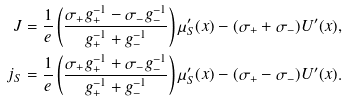Convert formula to latex. <formula><loc_0><loc_0><loc_500><loc_500>J = \frac { 1 } { e } \left ( \frac { \sigma _ { + } g ^ { - 1 } _ { + } - \sigma _ { - } g ^ { - 1 } _ { - } } { g ^ { - 1 } _ { + } + g ^ { - 1 } _ { - } } \right ) \mu ^ { \prime } _ { S } ( x ) - ( \sigma _ { + } + \sigma _ { - } ) U ^ { \prime } ( x ) , \\ j _ { S } = \frac { 1 } { e } \left ( \frac { \sigma _ { + } g ^ { - 1 } _ { + } + \sigma _ { - } g ^ { - 1 } _ { - } } { g ^ { - 1 } _ { + } + g ^ { - 1 } _ { - } } \right ) \mu ^ { \prime } _ { S } ( x ) - ( \sigma _ { + } - \sigma _ { - } ) U ^ { \prime } ( x ) .</formula> 